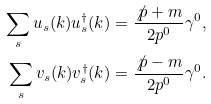<formula> <loc_0><loc_0><loc_500><loc_500>\sum _ { s } u _ { s } ( k ) u ^ { \dag } _ { s } ( k ) & = \frac { { \not p } + m } { 2 p ^ { 0 } } \gamma ^ { 0 } , \\ \sum _ { s } v _ { s } ( k ) v ^ { \dag } _ { s } ( k ) & = \frac { { \not p } - m } { 2 p ^ { 0 } } \gamma ^ { 0 } .</formula> 